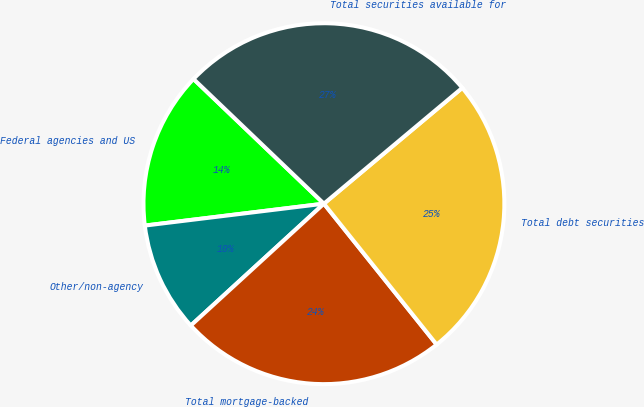Convert chart to OTSL. <chart><loc_0><loc_0><loc_500><loc_500><pie_chart><fcel>Federal agencies and US<fcel>Other/non-agency<fcel>Total mortgage-backed<fcel>Total debt securities<fcel>Total securities available for<nl><fcel>14.08%<fcel>9.86%<fcel>23.94%<fcel>25.35%<fcel>26.76%<nl></chart> 